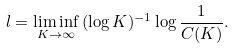<formula> <loc_0><loc_0><loc_500><loc_500>l = \liminf _ { K \rightarrow \infty } \, ( \log K ) ^ { - 1 } \log \frac { 1 } { C ( K ) } .</formula> 